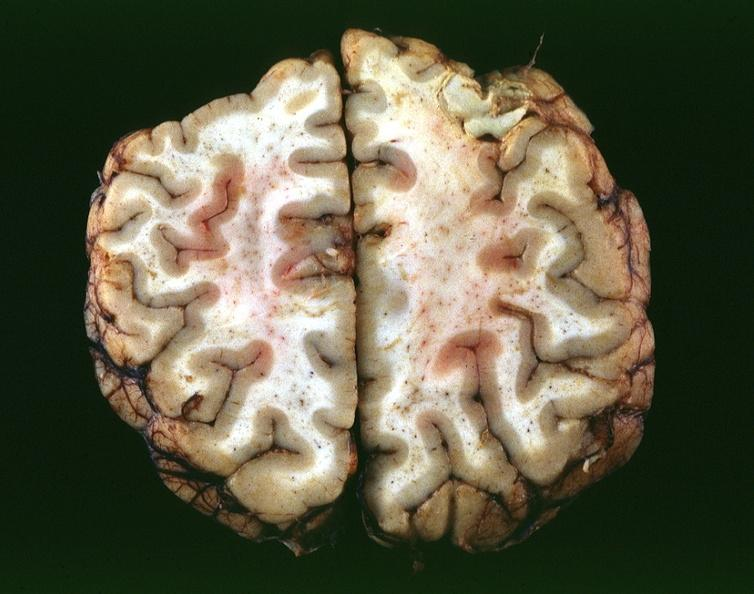s oil acid present?
Answer the question using a single word or phrase. No 